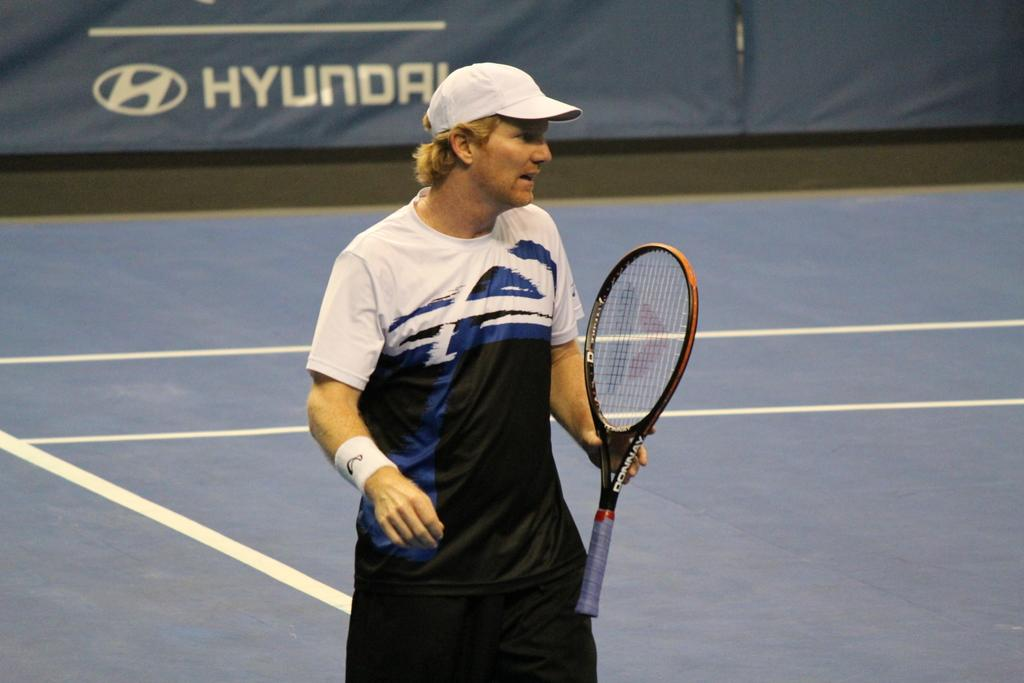What can be seen in the image? There is a person in the image. What is the person wearing? The person is wearing a t-shirt and a hat. What is the person doing in the image? The person is standing and holding a bat in their hand. What is visible in the background of the image? There is a banner and ground visible in the background of the image. What type of collar is the station wearing in the image? There is no station or collar present in the image. The image features a person wearing a t-shirt and a hat, holding a bat, and standing on the ground. 